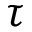<formula> <loc_0><loc_0><loc_500><loc_500>\tau</formula> 